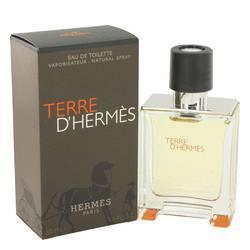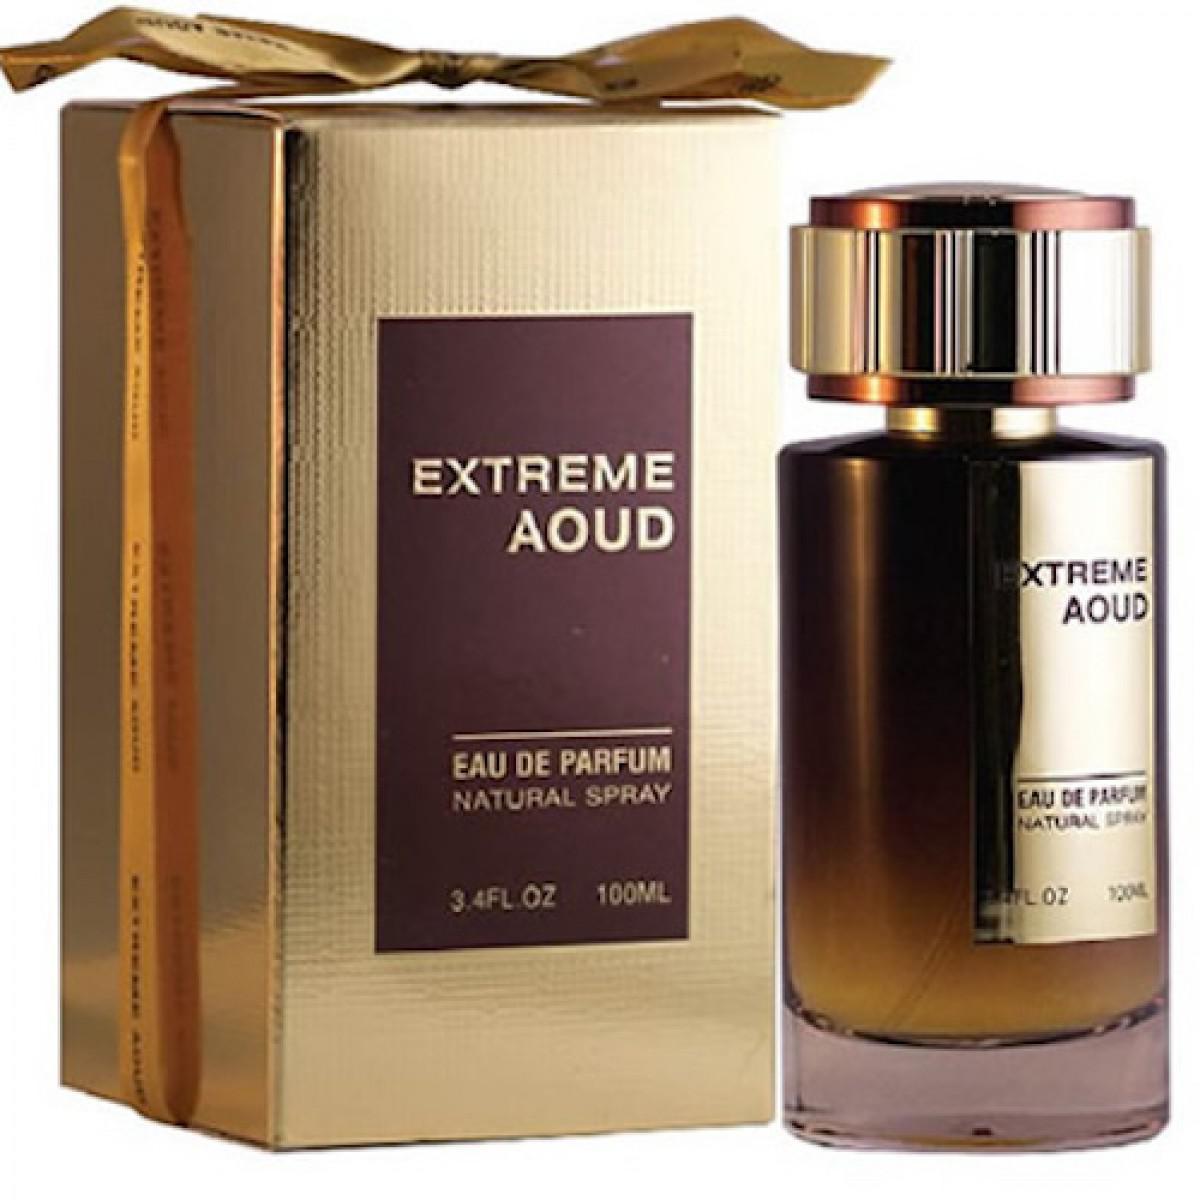The first image is the image on the left, the second image is the image on the right. For the images shown, is this caption "All of the perfumes are in a square shaped bottle." true? Answer yes or no. No. The first image is the image on the left, the second image is the image on the right. Considering the images on both sides, is "The box in each picture is black" valid? Answer yes or no. No. 